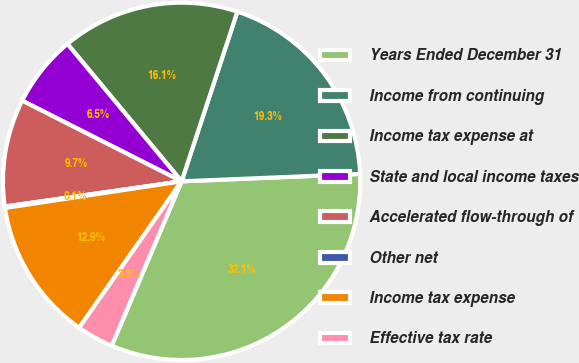Convert chart. <chart><loc_0><loc_0><loc_500><loc_500><pie_chart><fcel>Years Ended December 31<fcel>Income from continuing<fcel>Income tax expense at<fcel>State and local income taxes<fcel>Accelerated flow-through of<fcel>Other net<fcel>Income tax expense<fcel>Effective tax rate<nl><fcel>32.06%<fcel>19.29%<fcel>16.09%<fcel>6.51%<fcel>9.71%<fcel>0.13%<fcel>12.9%<fcel>3.32%<nl></chart> 